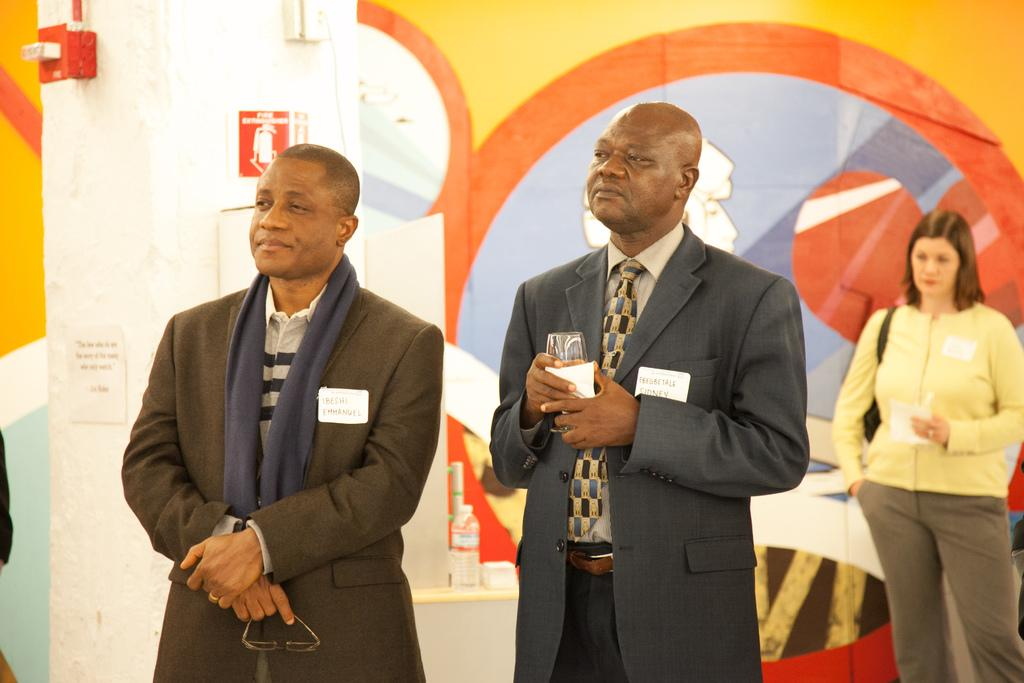How many people are in the center of the image? There are two men standing in the center of the image. What can be seen in the background of the image? There is a woman, a wall, and a pillar in the background of the image. What type of cork can be seen in the hands of the men in the image? There is no cork present in the image; the men are not holding anything. What kind of music is being played in the background of the image? There is no music present in the image; it is a still photograph. 